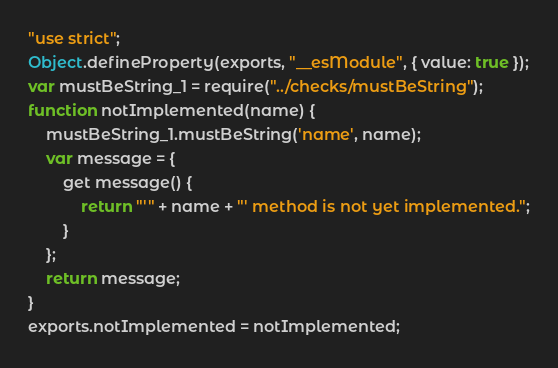Convert code to text. <code><loc_0><loc_0><loc_500><loc_500><_JavaScript_>"use strict";
Object.defineProperty(exports, "__esModule", { value: true });
var mustBeString_1 = require("../checks/mustBeString");
function notImplemented(name) {
    mustBeString_1.mustBeString('name', name);
    var message = {
        get message() {
            return "'" + name + "' method is not yet implemented.";
        }
    };
    return message;
}
exports.notImplemented = notImplemented;
</code> 